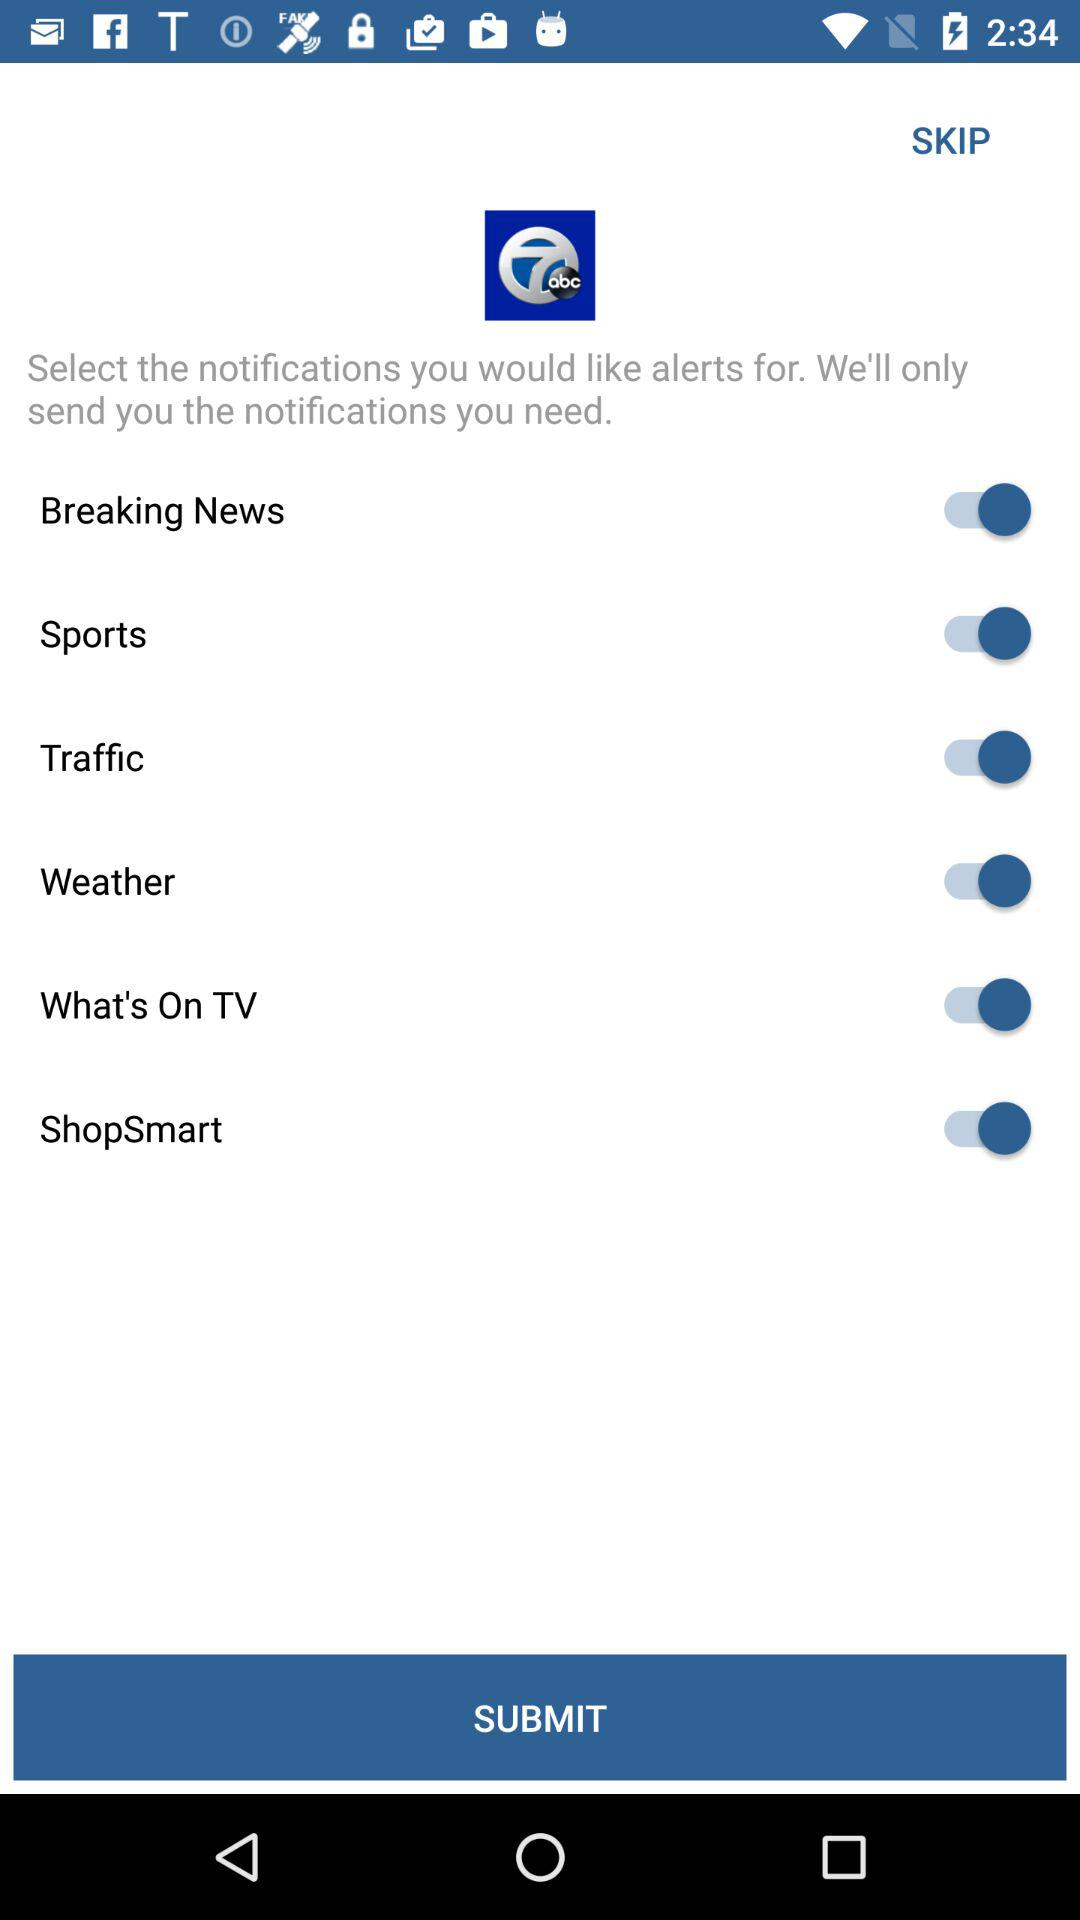What is the status of the "ShopSmart"? The status is on. 